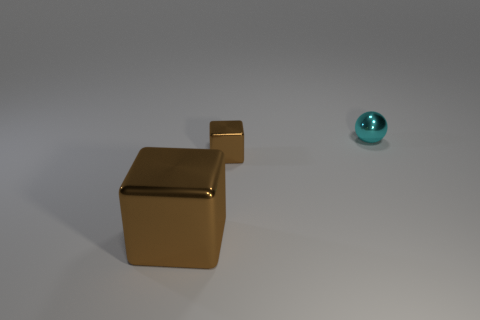What can you infer about the size of the room based on the objects and shadows? Based on the objects and their shadows, it's not possible to discern the exact size of the room, as it’s an abstract representation. However, the distance between shadows suggests a spacious environment, and the lack of any distinct background features leaves the room's dimensions up to interpretation. 